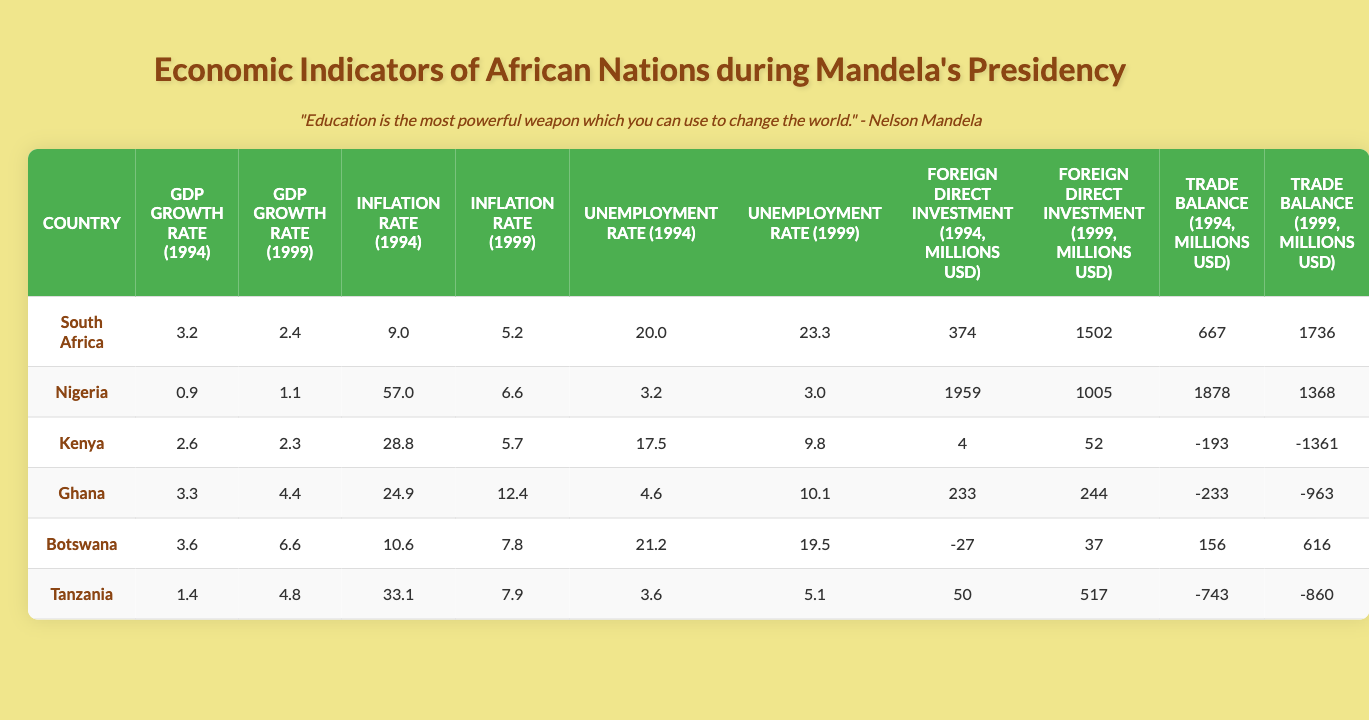What was the GDP growth rate of South Africa in 1994? The table shows that the GDP growth rate for South Africa in 1994 is 3.2%.
Answer: 3.2% Which country had the highest inflation rate in 1994? By comparing the inflation rates in 1994 for all countries, Nigeria has the highest inflation rate at 57.0%.
Answer: Nigeria What was the unemployment rate in Ghana in 1999? The table indicates that the unemployment rate for Ghana in 1999 is 10.1%.
Answer: 10.1% What is the difference in foreign direct investment for Botswana from 1994 to 1999? The foreign direct investment for Botswana in 1994 was -27 million USD, and in 1999 it was 37 million USD. The difference is 37 - (-27) = 64 million USD.
Answer: 64 million USD Which country saw a decrease in GDP growth rate from 1994 to 1999? The table shows that Nigeria's GDP growth rate decreased from 0.9% in 1994 to 1.1% in 1999, indicating it did not decrease. South Africa also saw a decrease from 3.2% in 1994 to 2.4% in 1999, confirming it decreased.
Answer: South Africa Was the trade balance of Kenya positive or negative in 1999? Kenya's trade balance in 1999 is -1361 million USD, which is negative.
Answer: Negative What was the average GDP growth rate for the countries listed in 1994? The GDP growth rates in 1994 are 3.2, 0.9, 2.6, 3.3, 3.6, and 1.4. The sum is 3.2 + 0.9 + 2.6 + 3.3 + 3.6 + 1.4 = 15.0, and the average is 15.0 / 6 = 2.5.
Answer: 2.5 Which country had the lowest unemployment rate in 1994? The table shows that Nigeria had the lowest unemployment rate in 1994 at 3.2%.
Answer: Nigeria How much did the trade balance of Tanzania change between 1994 and 1999? Tanzania had a trade balance of -743 million USD in 1994 and -860 million USD in 1999. The change is -860 - (-743) = -117 million USD, indicating a worsening trade balance.
Answer: -117 million USD Is it true that all the listed countries experienced a decrease in inflation from 1994 to 1999? By examining the inflation rates in the table, all countries listed show a decrease in inflation rates from 1994 to 1999.
Answer: True 